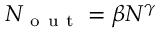<formula> <loc_0><loc_0><loc_500><loc_500>N _ { o u t } = \beta N ^ { \gamma }</formula> 